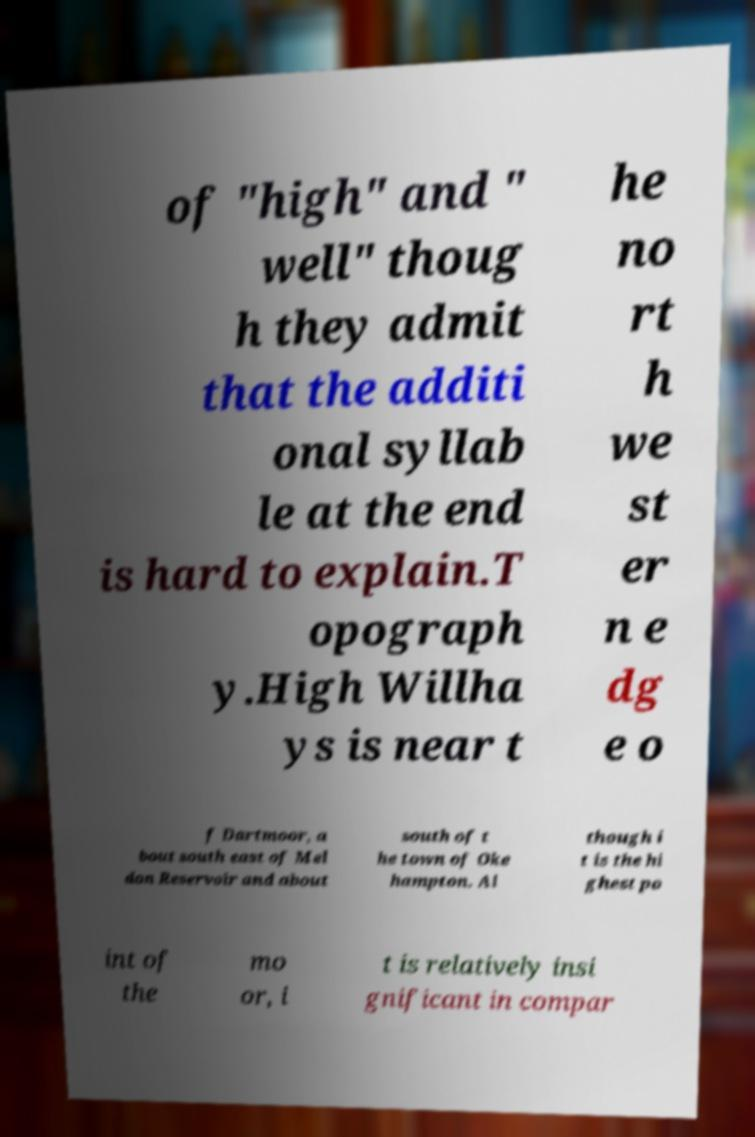There's text embedded in this image that I need extracted. Can you transcribe it verbatim? of "high" and " well" thoug h they admit that the additi onal syllab le at the end is hard to explain.T opograph y.High Willha ys is near t he no rt h we st er n e dg e o f Dartmoor, a bout south east of Mel don Reservoir and about south of t he town of Oke hampton. Al though i t is the hi ghest po int of the mo or, i t is relatively insi gnificant in compar 